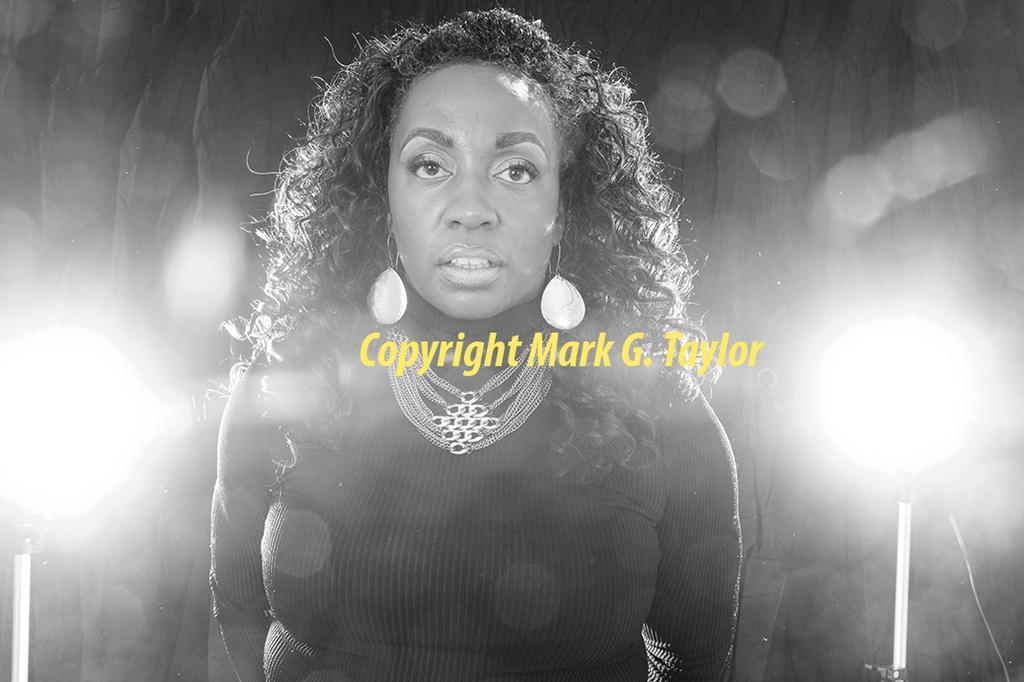Can you describe this image briefly? In this picture there is a woman wearing black color dress with necklace, standing and giving a pose into the camera. Behind there is a blur background with spotlights. 